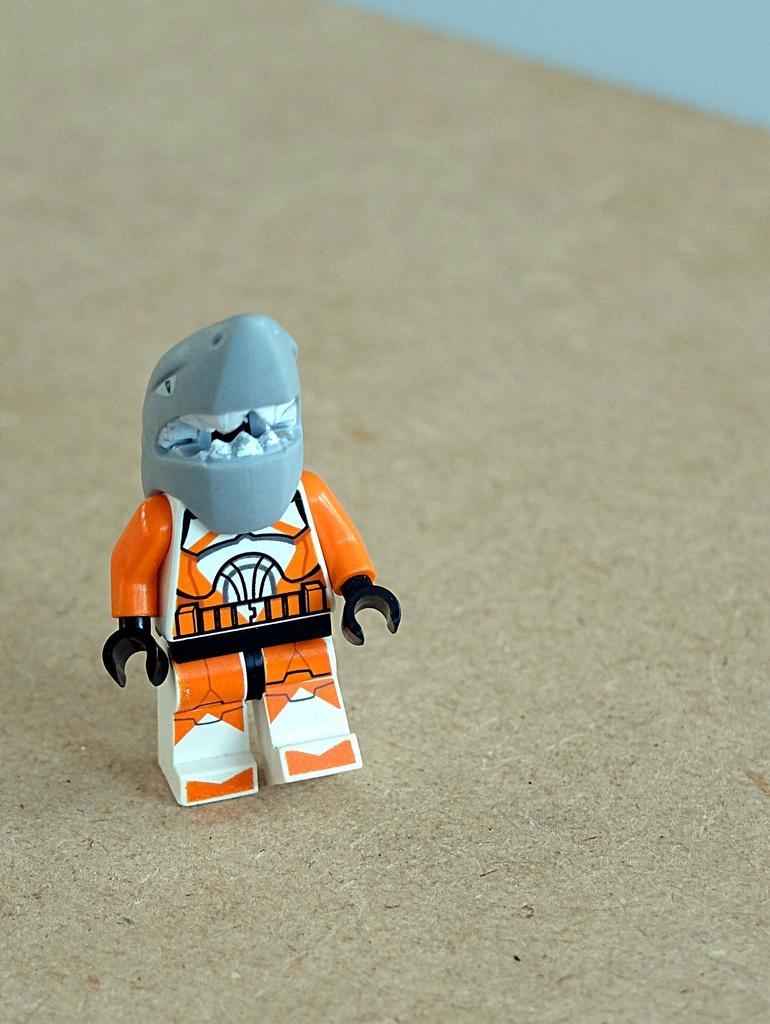Can you describe this image briefly? In this picture we can see a toy on the platform. 